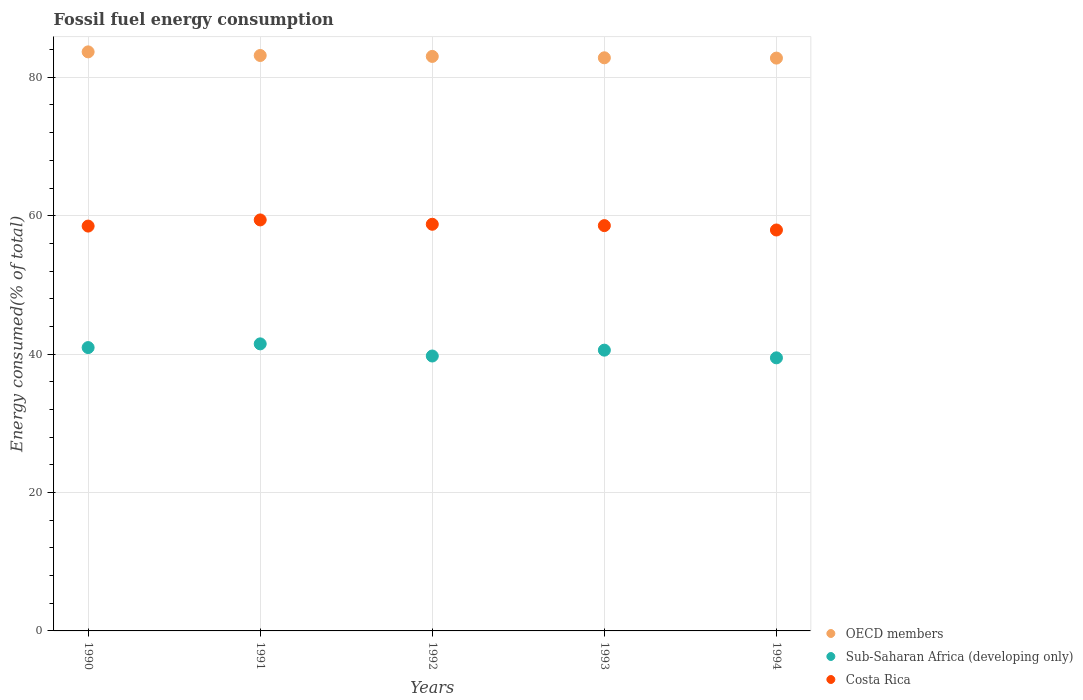Is the number of dotlines equal to the number of legend labels?
Your answer should be very brief. Yes. What is the percentage of energy consumed in OECD members in 1991?
Ensure brevity in your answer.  83.16. Across all years, what is the maximum percentage of energy consumed in Sub-Saharan Africa (developing only)?
Give a very brief answer. 41.48. Across all years, what is the minimum percentage of energy consumed in Sub-Saharan Africa (developing only)?
Make the answer very short. 39.46. What is the total percentage of energy consumed in OECD members in the graph?
Keep it short and to the point. 415.45. What is the difference between the percentage of energy consumed in Sub-Saharan Africa (developing only) in 1993 and that in 1994?
Your response must be concise. 1.11. What is the difference between the percentage of energy consumed in Sub-Saharan Africa (developing only) in 1991 and the percentage of energy consumed in Costa Rica in 1990?
Your answer should be very brief. -17.02. What is the average percentage of energy consumed in OECD members per year?
Make the answer very short. 83.09. In the year 1993, what is the difference between the percentage of energy consumed in Costa Rica and percentage of energy consumed in Sub-Saharan Africa (developing only)?
Your response must be concise. 18. In how many years, is the percentage of energy consumed in Costa Rica greater than 64 %?
Provide a succinct answer. 0. What is the ratio of the percentage of energy consumed in OECD members in 1992 to that in 1993?
Offer a terse response. 1. Is the difference between the percentage of energy consumed in Costa Rica in 1990 and 1994 greater than the difference between the percentage of energy consumed in Sub-Saharan Africa (developing only) in 1990 and 1994?
Provide a succinct answer. No. What is the difference between the highest and the second highest percentage of energy consumed in Sub-Saharan Africa (developing only)?
Keep it short and to the point. 0.54. What is the difference between the highest and the lowest percentage of energy consumed in Costa Rica?
Keep it short and to the point. 1.46. In how many years, is the percentage of energy consumed in Sub-Saharan Africa (developing only) greater than the average percentage of energy consumed in Sub-Saharan Africa (developing only) taken over all years?
Offer a very short reply. 3. Is it the case that in every year, the sum of the percentage of energy consumed in Costa Rica and percentage of energy consumed in OECD members  is greater than the percentage of energy consumed in Sub-Saharan Africa (developing only)?
Ensure brevity in your answer.  Yes. Does the percentage of energy consumed in Costa Rica monotonically increase over the years?
Your response must be concise. No. Are the values on the major ticks of Y-axis written in scientific E-notation?
Ensure brevity in your answer.  No. Does the graph contain any zero values?
Your response must be concise. No. Does the graph contain grids?
Your answer should be compact. Yes. How many legend labels are there?
Offer a very short reply. 3. How are the legend labels stacked?
Provide a succinct answer. Vertical. What is the title of the graph?
Keep it short and to the point. Fossil fuel energy consumption. Does "Kenya" appear as one of the legend labels in the graph?
Offer a very short reply. No. What is the label or title of the X-axis?
Keep it short and to the point. Years. What is the label or title of the Y-axis?
Your answer should be very brief. Energy consumed(% of total). What is the Energy consumed(% of total) in OECD members in 1990?
Provide a short and direct response. 83.68. What is the Energy consumed(% of total) in Sub-Saharan Africa (developing only) in 1990?
Keep it short and to the point. 40.95. What is the Energy consumed(% of total) in Costa Rica in 1990?
Your answer should be very brief. 58.5. What is the Energy consumed(% of total) in OECD members in 1991?
Provide a short and direct response. 83.16. What is the Energy consumed(% of total) of Sub-Saharan Africa (developing only) in 1991?
Offer a very short reply. 41.48. What is the Energy consumed(% of total) in Costa Rica in 1991?
Your answer should be very brief. 59.39. What is the Energy consumed(% of total) in OECD members in 1992?
Provide a short and direct response. 83.02. What is the Energy consumed(% of total) of Sub-Saharan Africa (developing only) in 1992?
Offer a very short reply. 39.73. What is the Energy consumed(% of total) in Costa Rica in 1992?
Your response must be concise. 58.76. What is the Energy consumed(% of total) in OECD members in 1993?
Make the answer very short. 82.82. What is the Energy consumed(% of total) of Sub-Saharan Africa (developing only) in 1993?
Offer a terse response. 40.57. What is the Energy consumed(% of total) in Costa Rica in 1993?
Your answer should be compact. 58.57. What is the Energy consumed(% of total) in OECD members in 1994?
Give a very brief answer. 82.78. What is the Energy consumed(% of total) of Sub-Saharan Africa (developing only) in 1994?
Make the answer very short. 39.46. What is the Energy consumed(% of total) in Costa Rica in 1994?
Make the answer very short. 57.94. Across all years, what is the maximum Energy consumed(% of total) in OECD members?
Your answer should be compact. 83.68. Across all years, what is the maximum Energy consumed(% of total) in Sub-Saharan Africa (developing only)?
Keep it short and to the point. 41.48. Across all years, what is the maximum Energy consumed(% of total) in Costa Rica?
Provide a succinct answer. 59.39. Across all years, what is the minimum Energy consumed(% of total) in OECD members?
Your response must be concise. 82.78. Across all years, what is the minimum Energy consumed(% of total) of Sub-Saharan Africa (developing only)?
Your answer should be very brief. 39.46. Across all years, what is the minimum Energy consumed(% of total) in Costa Rica?
Offer a terse response. 57.94. What is the total Energy consumed(% of total) in OECD members in the graph?
Ensure brevity in your answer.  415.45. What is the total Energy consumed(% of total) in Sub-Saharan Africa (developing only) in the graph?
Provide a short and direct response. 202.19. What is the total Energy consumed(% of total) in Costa Rica in the graph?
Keep it short and to the point. 293.17. What is the difference between the Energy consumed(% of total) of OECD members in 1990 and that in 1991?
Your answer should be very brief. 0.52. What is the difference between the Energy consumed(% of total) of Sub-Saharan Africa (developing only) in 1990 and that in 1991?
Keep it short and to the point. -0.54. What is the difference between the Energy consumed(% of total) in Costa Rica in 1990 and that in 1991?
Keep it short and to the point. -0.89. What is the difference between the Energy consumed(% of total) in OECD members in 1990 and that in 1992?
Give a very brief answer. 0.66. What is the difference between the Energy consumed(% of total) in Sub-Saharan Africa (developing only) in 1990 and that in 1992?
Provide a short and direct response. 1.22. What is the difference between the Energy consumed(% of total) of Costa Rica in 1990 and that in 1992?
Offer a terse response. -0.26. What is the difference between the Energy consumed(% of total) in OECD members in 1990 and that in 1993?
Offer a very short reply. 0.86. What is the difference between the Energy consumed(% of total) of Sub-Saharan Africa (developing only) in 1990 and that in 1993?
Make the answer very short. 0.37. What is the difference between the Energy consumed(% of total) of Costa Rica in 1990 and that in 1993?
Make the answer very short. -0.07. What is the difference between the Energy consumed(% of total) in OECD members in 1990 and that in 1994?
Ensure brevity in your answer.  0.9. What is the difference between the Energy consumed(% of total) of Sub-Saharan Africa (developing only) in 1990 and that in 1994?
Offer a very short reply. 1.48. What is the difference between the Energy consumed(% of total) of Costa Rica in 1990 and that in 1994?
Give a very brief answer. 0.57. What is the difference between the Energy consumed(% of total) of OECD members in 1991 and that in 1992?
Your response must be concise. 0.13. What is the difference between the Energy consumed(% of total) in Sub-Saharan Africa (developing only) in 1991 and that in 1992?
Offer a terse response. 1.76. What is the difference between the Energy consumed(% of total) in Costa Rica in 1991 and that in 1992?
Provide a succinct answer. 0.63. What is the difference between the Energy consumed(% of total) of OECD members in 1991 and that in 1993?
Keep it short and to the point. 0.33. What is the difference between the Energy consumed(% of total) of Sub-Saharan Africa (developing only) in 1991 and that in 1993?
Give a very brief answer. 0.91. What is the difference between the Energy consumed(% of total) of Costa Rica in 1991 and that in 1993?
Offer a terse response. 0.82. What is the difference between the Energy consumed(% of total) of OECD members in 1991 and that in 1994?
Your response must be concise. 0.38. What is the difference between the Energy consumed(% of total) in Sub-Saharan Africa (developing only) in 1991 and that in 1994?
Give a very brief answer. 2.02. What is the difference between the Energy consumed(% of total) in Costa Rica in 1991 and that in 1994?
Keep it short and to the point. 1.46. What is the difference between the Energy consumed(% of total) of OECD members in 1992 and that in 1993?
Provide a succinct answer. 0.2. What is the difference between the Energy consumed(% of total) in Sub-Saharan Africa (developing only) in 1992 and that in 1993?
Provide a short and direct response. -0.85. What is the difference between the Energy consumed(% of total) of Costa Rica in 1992 and that in 1993?
Your response must be concise. 0.19. What is the difference between the Energy consumed(% of total) of OECD members in 1992 and that in 1994?
Keep it short and to the point. 0.24. What is the difference between the Energy consumed(% of total) in Sub-Saharan Africa (developing only) in 1992 and that in 1994?
Your answer should be very brief. 0.26. What is the difference between the Energy consumed(% of total) in Costa Rica in 1992 and that in 1994?
Offer a very short reply. 0.83. What is the difference between the Energy consumed(% of total) in OECD members in 1993 and that in 1994?
Keep it short and to the point. 0.04. What is the difference between the Energy consumed(% of total) of Sub-Saharan Africa (developing only) in 1993 and that in 1994?
Ensure brevity in your answer.  1.11. What is the difference between the Energy consumed(% of total) of Costa Rica in 1993 and that in 1994?
Your response must be concise. 0.63. What is the difference between the Energy consumed(% of total) in OECD members in 1990 and the Energy consumed(% of total) in Sub-Saharan Africa (developing only) in 1991?
Your answer should be very brief. 42.2. What is the difference between the Energy consumed(% of total) of OECD members in 1990 and the Energy consumed(% of total) of Costa Rica in 1991?
Your answer should be compact. 24.28. What is the difference between the Energy consumed(% of total) of Sub-Saharan Africa (developing only) in 1990 and the Energy consumed(% of total) of Costa Rica in 1991?
Your response must be concise. -18.45. What is the difference between the Energy consumed(% of total) of OECD members in 1990 and the Energy consumed(% of total) of Sub-Saharan Africa (developing only) in 1992?
Your answer should be compact. 43.95. What is the difference between the Energy consumed(% of total) in OECD members in 1990 and the Energy consumed(% of total) in Costa Rica in 1992?
Provide a succinct answer. 24.91. What is the difference between the Energy consumed(% of total) of Sub-Saharan Africa (developing only) in 1990 and the Energy consumed(% of total) of Costa Rica in 1992?
Your answer should be very brief. -17.82. What is the difference between the Energy consumed(% of total) of OECD members in 1990 and the Energy consumed(% of total) of Sub-Saharan Africa (developing only) in 1993?
Your answer should be compact. 43.1. What is the difference between the Energy consumed(% of total) in OECD members in 1990 and the Energy consumed(% of total) in Costa Rica in 1993?
Make the answer very short. 25.11. What is the difference between the Energy consumed(% of total) in Sub-Saharan Africa (developing only) in 1990 and the Energy consumed(% of total) in Costa Rica in 1993?
Your answer should be very brief. -17.63. What is the difference between the Energy consumed(% of total) in OECD members in 1990 and the Energy consumed(% of total) in Sub-Saharan Africa (developing only) in 1994?
Your response must be concise. 44.21. What is the difference between the Energy consumed(% of total) of OECD members in 1990 and the Energy consumed(% of total) of Costa Rica in 1994?
Your response must be concise. 25.74. What is the difference between the Energy consumed(% of total) of Sub-Saharan Africa (developing only) in 1990 and the Energy consumed(% of total) of Costa Rica in 1994?
Offer a terse response. -16.99. What is the difference between the Energy consumed(% of total) of OECD members in 1991 and the Energy consumed(% of total) of Sub-Saharan Africa (developing only) in 1992?
Your response must be concise. 43.43. What is the difference between the Energy consumed(% of total) in OECD members in 1991 and the Energy consumed(% of total) in Costa Rica in 1992?
Offer a very short reply. 24.39. What is the difference between the Energy consumed(% of total) in Sub-Saharan Africa (developing only) in 1991 and the Energy consumed(% of total) in Costa Rica in 1992?
Your answer should be compact. -17.28. What is the difference between the Energy consumed(% of total) in OECD members in 1991 and the Energy consumed(% of total) in Sub-Saharan Africa (developing only) in 1993?
Keep it short and to the point. 42.58. What is the difference between the Energy consumed(% of total) in OECD members in 1991 and the Energy consumed(% of total) in Costa Rica in 1993?
Provide a succinct answer. 24.58. What is the difference between the Energy consumed(% of total) in Sub-Saharan Africa (developing only) in 1991 and the Energy consumed(% of total) in Costa Rica in 1993?
Provide a short and direct response. -17.09. What is the difference between the Energy consumed(% of total) of OECD members in 1991 and the Energy consumed(% of total) of Sub-Saharan Africa (developing only) in 1994?
Ensure brevity in your answer.  43.69. What is the difference between the Energy consumed(% of total) in OECD members in 1991 and the Energy consumed(% of total) in Costa Rica in 1994?
Make the answer very short. 25.22. What is the difference between the Energy consumed(% of total) of Sub-Saharan Africa (developing only) in 1991 and the Energy consumed(% of total) of Costa Rica in 1994?
Offer a terse response. -16.45. What is the difference between the Energy consumed(% of total) of OECD members in 1992 and the Energy consumed(% of total) of Sub-Saharan Africa (developing only) in 1993?
Keep it short and to the point. 42.45. What is the difference between the Energy consumed(% of total) in OECD members in 1992 and the Energy consumed(% of total) in Costa Rica in 1993?
Keep it short and to the point. 24.45. What is the difference between the Energy consumed(% of total) in Sub-Saharan Africa (developing only) in 1992 and the Energy consumed(% of total) in Costa Rica in 1993?
Ensure brevity in your answer.  -18.84. What is the difference between the Energy consumed(% of total) of OECD members in 1992 and the Energy consumed(% of total) of Sub-Saharan Africa (developing only) in 1994?
Keep it short and to the point. 43.56. What is the difference between the Energy consumed(% of total) of OECD members in 1992 and the Energy consumed(% of total) of Costa Rica in 1994?
Provide a succinct answer. 25.08. What is the difference between the Energy consumed(% of total) in Sub-Saharan Africa (developing only) in 1992 and the Energy consumed(% of total) in Costa Rica in 1994?
Ensure brevity in your answer.  -18.21. What is the difference between the Energy consumed(% of total) of OECD members in 1993 and the Energy consumed(% of total) of Sub-Saharan Africa (developing only) in 1994?
Your response must be concise. 43.36. What is the difference between the Energy consumed(% of total) in OECD members in 1993 and the Energy consumed(% of total) in Costa Rica in 1994?
Your answer should be very brief. 24.88. What is the difference between the Energy consumed(% of total) of Sub-Saharan Africa (developing only) in 1993 and the Energy consumed(% of total) of Costa Rica in 1994?
Keep it short and to the point. -17.36. What is the average Energy consumed(% of total) in OECD members per year?
Ensure brevity in your answer.  83.09. What is the average Energy consumed(% of total) of Sub-Saharan Africa (developing only) per year?
Ensure brevity in your answer.  40.44. What is the average Energy consumed(% of total) of Costa Rica per year?
Offer a terse response. 58.63. In the year 1990, what is the difference between the Energy consumed(% of total) in OECD members and Energy consumed(% of total) in Sub-Saharan Africa (developing only)?
Your answer should be compact. 42.73. In the year 1990, what is the difference between the Energy consumed(% of total) of OECD members and Energy consumed(% of total) of Costa Rica?
Your answer should be compact. 25.17. In the year 1990, what is the difference between the Energy consumed(% of total) of Sub-Saharan Africa (developing only) and Energy consumed(% of total) of Costa Rica?
Your answer should be compact. -17.56. In the year 1991, what is the difference between the Energy consumed(% of total) in OECD members and Energy consumed(% of total) in Sub-Saharan Africa (developing only)?
Your response must be concise. 41.67. In the year 1991, what is the difference between the Energy consumed(% of total) of OECD members and Energy consumed(% of total) of Costa Rica?
Your response must be concise. 23.76. In the year 1991, what is the difference between the Energy consumed(% of total) of Sub-Saharan Africa (developing only) and Energy consumed(% of total) of Costa Rica?
Give a very brief answer. -17.91. In the year 1992, what is the difference between the Energy consumed(% of total) in OECD members and Energy consumed(% of total) in Sub-Saharan Africa (developing only)?
Make the answer very short. 43.29. In the year 1992, what is the difference between the Energy consumed(% of total) of OECD members and Energy consumed(% of total) of Costa Rica?
Ensure brevity in your answer.  24.26. In the year 1992, what is the difference between the Energy consumed(% of total) in Sub-Saharan Africa (developing only) and Energy consumed(% of total) in Costa Rica?
Ensure brevity in your answer.  -19.04. In the year 1993, what is the difference between the Energy consumed(% of total) in OECD members and Energy consumed(% of total) in Sub-Saharan Africa (developing only)?
Your response must be concise. 42.25. In the year 1993, what is the difference between the Energy consumed(% of total) in OECD members and Energy consumed(% of total) in Costa Rica?
Make the answer very short. 24.25. In the year 1993, what is the difference between the Energy consumed(% of total) in Sub-Saharan Africa (developing only) and Energy consumed(% of total) in Costa Rica?
Provide a short and direct response. -18. In the year 1994, what is the difference between the Energy consumed(% of total) of OECD members and Energy consumed(% of total) of Sub-Saharan Africa (developing only)?
Provide a short and direct response. 43.31. In the year 1994, what is the difference between the Energy consumed(% of total) in OECD members and Energy consumed(% of total) in Costa Rica?
Ensure brevity in your answer.  24.84. In the year 1994, what is the difference between the Energy consumed(% of total) of Sub-Saharan Africa (developing only) and Energy consumed(% of total) of Costa Rica?
Offer a terse response. -18.47. What is the ratio of the Energy consumed(% of total) of OECD members in 1990 to that in 1991?
Provide a short and direct response. 1.01. What is the ratio of the Energy consumed(% of total) in Sub-Saharan Africa (developing only) in 1990 to that in 1991?
Your answer should be very brief. 0.99. What is the ratio of the Energy consumed(% of total) of Costa Rica in 1990 to that in 1991?
Provide a succinct answer. 0.98. What is the ratio of the Energy consumed(% of total) in OECD members in 1990 to that in 1992?
Your answer should be compact. 1.01. What is the ratio of the Energy consumed(% of total) in Sub-Saharan Africa (developing only) in 1990 to that in 1992?
Give a very brief answer. 1.03. What is the ratio of the Energy consumed(% of total) in OECD members in 1990 to that in 1993?
Keep it short and to the point. 1.01. What is the ratio of the Energy consumed(% of total) of Sub-Saharan Africa (developing only) in 1990 to that in 1993?
Your response must be concise. 1.01. What is the ratio of the Energy consumed(% of total) in Costa Rica in 1990 to that in 1993?
Make the answer very short. 1. What is the ratio of the Energy consumed(% of total) of OECD members in 1990 to that in 1994?
Keep it short and to the point. 1.01. What is the ratio of the Energy consumed(% of total) in Sub-Saharan Africa (developing only) in 1990 to that in 1994?
Make the answer very short. 1.04. What is the ratio of the Energy consumed(% of total) of Costa Rica in 1990 to that in 1994?
Provide a short and direct response. 1.01. What is the ratio of the Energy consumed(% of total) of Sub-Saharan Africa (developing only) in 1991 to that in 1992?
Your response must be concise. 1.04. What is the ratio of the Energy consumed(% of total) of Costa Rica in 1991 to that in 1992?
Ensure brevity in your answer.  1.01. What is the ratio of the Energy consumed(% of total) in Sub-Saharan Africa (developing only) in 1991 to that in 1993?
Provide a succinct answer. 1.02. What is the ratio of the Energy consumed(% of total) of OECD members in 1991 to that in 1994?
Your answer should be compact. 1. What is the ratio of the Energy consumed(% of total) of Sub-Saharan Africa (developing only) in 1991 to that in 1994?
Keep it short and to the point. 1.05. What is the ratio of the Energy consumed(% of total) of Costa Rica in 1991 to that in 1994?
Make the answer very short. 1.03. What is the ratio of the Energy consumed(% of total) of OECD members in 1992 to that in 1993?
Give a very brief answer. 1. What is the ratio of the Energy consumed(% of total) of Sub-Saharan Africa (developing only) in 1992 to that in 1993?
Provide a succinct answer. 0.98. What is the ratio of the Energy consumed(% of total) in Costa Rica in 1992 to that in 1993?
Make the answer very short. 1. What is the ratio of the Energy consumed(% of total) in Costa Rica in 1992 to that in 1994?
Your answer should be compact. 1.01. What is the ratio of the Energy consumed(% of total) of OECD members in 1993 to that in 1994?
Keep it short and to the point. 1. What is the ratio of the Energy consumed(% of total) of Sub-Saharan Africa (developing only) in 1993 to that in 1994?
Ensure brevity in your answer.  1.03. What is the ratio of the Energy consumed(% of total) of Costa Rica in 1993 to that in 1994?
Your response must be concise. 1.01. What is the difference between the highest and the second highest Energy consumed(% of total) in OECD members?
Provide a short and direct response. 0.52. What is the difference between the highest and the second highest Energy consumed(% of total) in Sub-Saharan Africa (developing only)?
Your answer should be very brief. 0.54. What is the difference between the highest and the second highest Energy consumed(% of total) of Costa Rica?
Make the answer very short. 0.63. What is the difference between the highest and the lowest Energy consumed(% of total) in OECD members?
Ensure brevity in your answer.  0.9. What is the difference between the highest and the lowest Energy consumed(% of total) in Sub-Saharan Africa (developing only)?
Ensure brevity in your answer.  2.02. What is the difference between the highest and the lowest Energy consumed(% of total) of Costa Rica?
Ensure brevity in your answer.  1.46. 